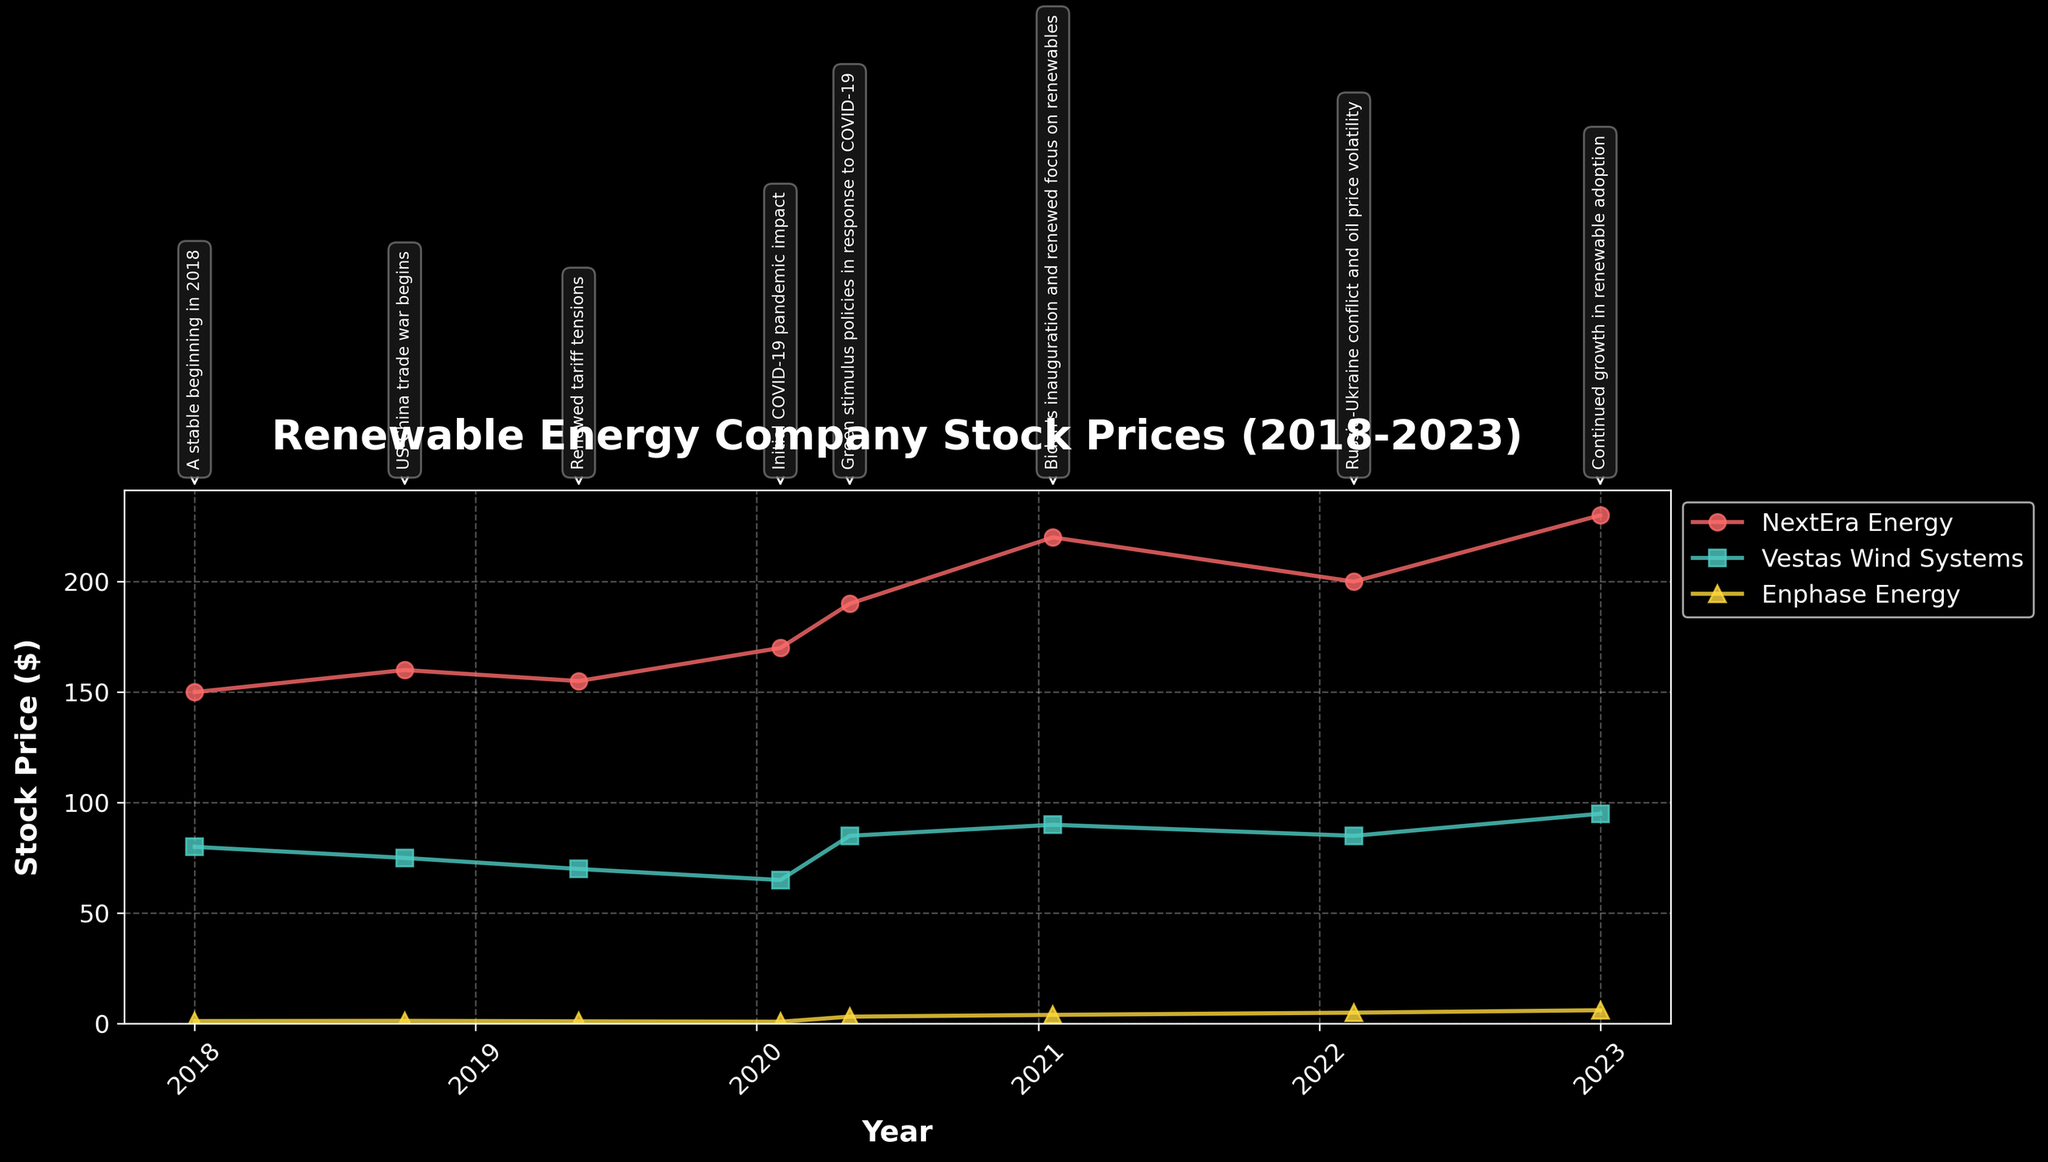what is the time range covered by the stock prices in the plot? The title of the plot states "Renewable Energy Company Stock Prices (2018-2023)". This indicates that the time range is from 2018 to 2023.
Answer: 2018 to 2023 Which company had the highest stock price at the end of 2023? By looking at the last data point on the plot, NextEra Energy had the highest stock price at around $230 in 2023.
Answer: NextEra Energy How did geopolitical events impact Enphase Energy’s stock price from 2020 to 2021? Initially, the stock price of Enphase Energy increased from around $0.9 in early 2020 to about $3.2 due to "Green stimulus policies in response to COVID-19" and later rose further to $4 following "Biden's inauguration and renewed focus on renewables".
Answer: Increased significantly What was the general trend in stock prices for Vestas Wind Systems during the time period? Vestas Wind Systems saw a slight decrease during the early geopolitical events, but then a significant increase around the "Green stimulus policies in response to COVID-19" in mid-2020, maintaining a relatively stable or slight growth post-2020.
Answer: Decreased initially, then increased around mid-2020 Comparing NextEra Energy and Vestas Wind Systems, which one had a higher stock price during the start of the US-China trade war in October 2018? In October 2018, NextEra Energy had a stock price of $160, whereas Vestas Wind Systems had a stock price of $75. Therefore, NextEra Energy had a higher stock price.
Answer: NextEra Energy What can be inferred from the stock price changes during "Renewed tariff tensions" in May 2019? All three companies' stock prices decreased during "Renewed tariff tensions" in May 2019. This indicates that renewed tariff tensions negatively impacted their stock prices.
Answer: Decreased for all companies How did NextEra Energy's stock price evolve during the COVID-19 pandemic? NextEra Energy's stock price increased from around $170 in early 2020 (Initial COVID-19 pandemic impact) to $190 in mid-2020 ("Green stimulus policies in response to COVID-19") and then further to $220 by January 2021 ("Biden's inauguration and renewed focus on renewables").
Answer: Increased consistently What is the comparison between the stock prices of all three companies as of January 2021? In January 2021:
- NextEra Energy: $220
- Vestas Wind Systems: $90
- Enphase Energy: $4
NextEra Energy had the highest stock price, followed by Vestas Wind Systems, and then Enphase Energy.
Answer: NextEra Energy > Vestas Wind Systems > Enphase Energy Which geopolitical event had the most positive influence on Enphase Energy’s stock? By looking at the plot, "Green stimulus policies in response to COVID-19" around May 2020 had the most positive influence as Enphase Energy's stock price saw a considerable jump from 0.9 to 3.2.
Answer: Green stimulus policies in response to COVID-19 